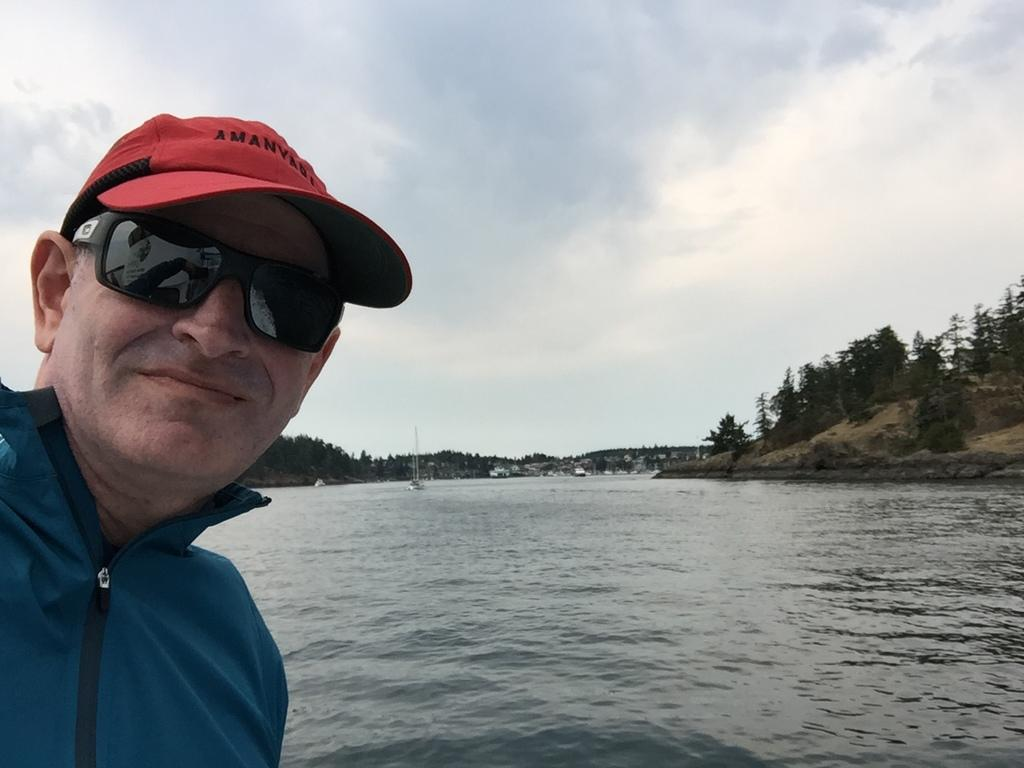Who is present in the image? There is a man in the image. What is the man's facial expression? The man is smiling. What can be seen in the background of the image? There is a lake, trees, hills, a motor vehicle, ships, and the sky visible in the background of the image. What is the condition of the sky in the image? The sky is visible in the background of the image, and there are clouds present. What type of sweater is the man wearing in the image? There is no sweater visible in the image; the man is not wearing any clothing. How does the man maintain his balance while walking on the water? The man is not walking on the water in the image; he is standing on the ground. 